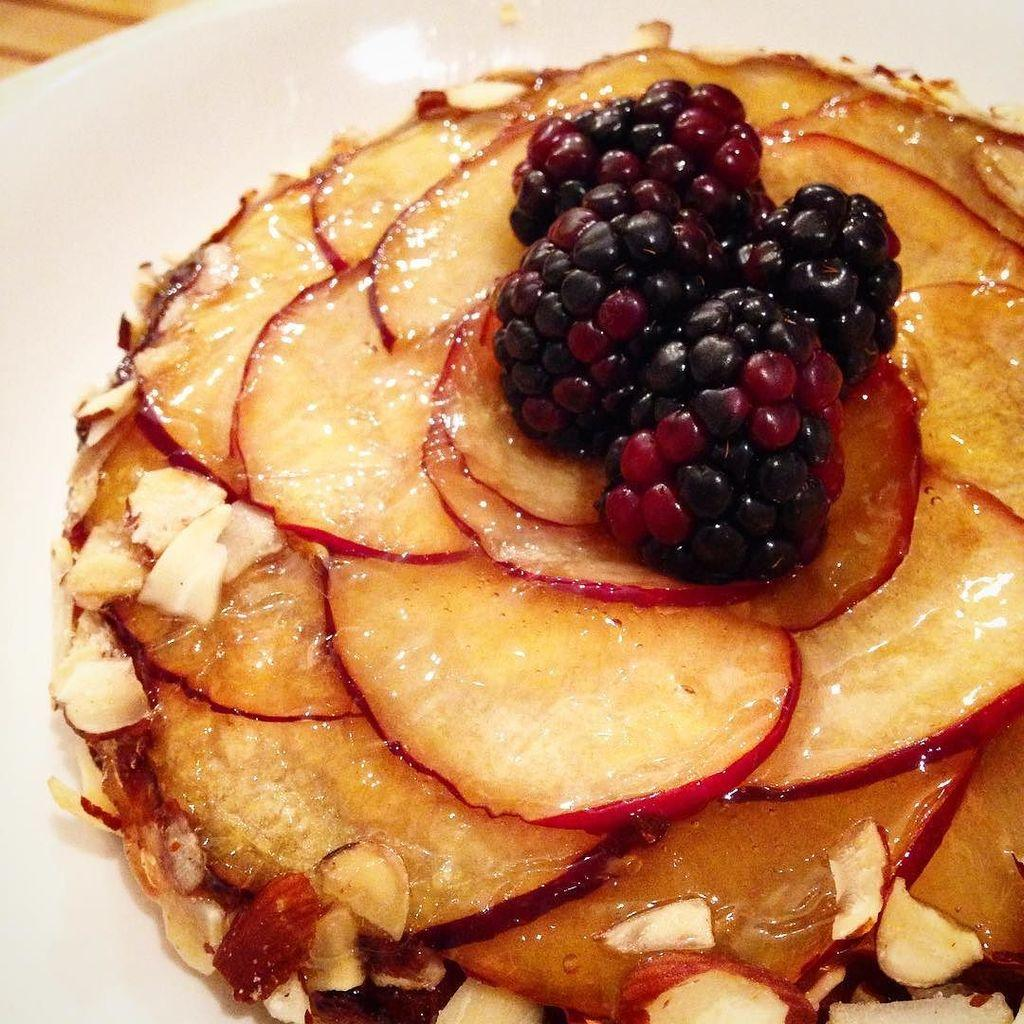What is on the plate in the image? There is food in the plate in the image. What type of food can be seen in the image? The food in the image includes berries. How many babies are crawling on the plate in the image? There are no babies present in the image; it only shows food and berries on a plate. What type of lizard can be seen hiding among the berries in the image? There are no lizards present in the image; it only shows food and berries on a plate. 